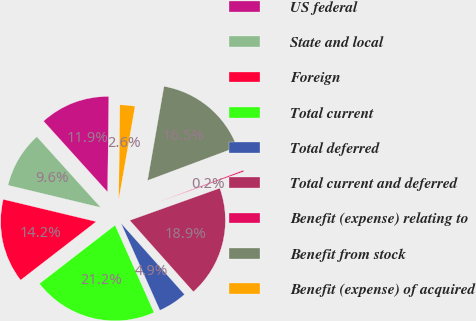Convert chart. <chart><loc_0><loc_0><loc_500><loc_500><pie_chart><fcel>US federal<fcel>State and local<fcel>Foreign<fcel>Total current<fcel>Total deferred<fcel>Total current and deferred<fcel>Benefit (expense) relating to<fcel>Benefit from stock<fcel>Benefit (expense) of acquired<nl><fcel>11.89%<fcel>9.56%<fcel>14.22%<fcel>21.21%<fcel>4.9%<fcel>18.88%<fcel>0.23%<fcel>16.55%<fcel>2.56%<nl></chart> 